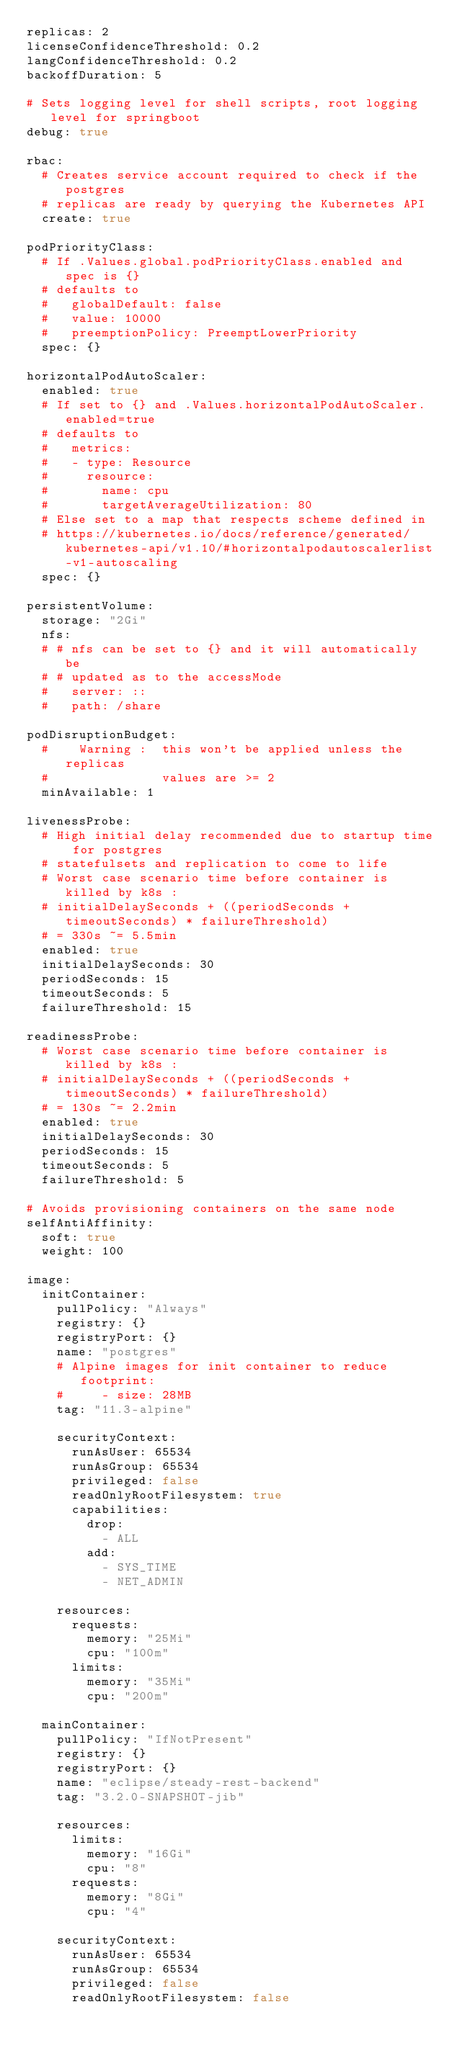<code> <loc_0><loc_0><loc_500><loc_500><_YAML_>replicas: 2
licenseConfidenceThreshold: 0.2
langConfidenceThreshold: 0.2
backoffDuration: 5

# Sets logging level for shell scripts, root logging level for springboot
debug: true

rbac:
  # Creates service account required to check if the postgres
  # replicas are ready by querying the Kubernetes API
  create: true

podPriorityClass:
  # If .Values.global.podPriorityClass.enabled and spec is {}
  # defaults to
  #   globalDefault: false
  #   value: 10000
  #   preemptionPolicy: PreemptLowerPriority
  spec: {}

horizontalPodAutoScaler:
  enabled: true
  # If set to {} and .Values.horizontalPodAutoScaler.enabled=true
  # defaults to
  #   metrics:
  #   - type: Resource
  #     resource:
  #       name: cpu
  #       targetAverageUtilization: 80
  # Else set to a map that respects scheme defined in
  # https://kubernetes.io/docs/reference/generated/kubernetes-api/v1.10/#horizontalpodautoscalerlist-v1-autoscaling
  spec: {}

persistentVolume: 
  storage: "2Gi"
  nfs:
  # # nfs can be set to {} and it will automatically be
  # # updated as to the accessMode
  #   server: ::
  #   path: /share

podDisruptionBudget:
  #    Warning :  this won't be applied unless the replicas
  #               values are >= 2
  minAvailable: 1

livenessProbe:
  # High initial delay recommended due to startup time for postgres
  # statefulsets and replication to come to life
  # Worst case scenario time before container is killed by k8s :
  # initialDelaySeconds + ((periodSeconds + timeoutSeconds) * failureThreshold)
  # = 330s ~= 5.5min
  enabled: true
  initialDelaySeconds: 30
  periodSeconds: 15
  timeoutSeconds: 5
  failureThreshold: 15

readinessProbe:
  # Worst case scenario time before container is killed by k8s :
  # initialDelaySeconds + ((periodSeconds + timeoutSeconds) * failureThreshold)
  # = 130s ~= 2.2min
  enabled: true
  initialDelaySeconds: 30
  periodSeconds: 15
  timeoutSeconds: 5
  failureThreshold: 5

# Avoids provisioning containers on the same node
selfAntiAffinity:
  soft: true
  weight: 100

image:
  initContainer:
    pullPolicy: "Always"
    registry: {}
    registryPort: {}
    name: "postgres"
    # Alpine images for init container to reduce footprint:
    #     - size: 28MB
    tag: "11.3-alpine"

    securityContext:
      runAsUser: 65534
      runAsGroup: 65534
      privileged: false
      readOnlyRootFilesystem: true
      capabilities:
        drop:
          - ALL
        add:
          - SYS_TIME
          - NET_ADMIN

    resources:
      requests:
        memory: "25Mi"
        cpu: "100m"
      limits:
        memory: "35Mi"
        cpu: "200m"

  mainContainer:
    pullPolicy: "IfNotPresent"
    registry: {}
    registryPort: {}
    name: "eclipse/steady-rest-backend"
    tag: "3.2.0-SNAPSHOT-jib"

    resources:
      limits:
        memory: "16Gi"
        cpu: "8"
      requests:
        memory: "8Gi"
        cpu: "4"

    securityContext:
      runAsUser: 65534
      runAsGroup: 65534
      privileged: false
      readOnlyRootFilesystem: false
</code> 